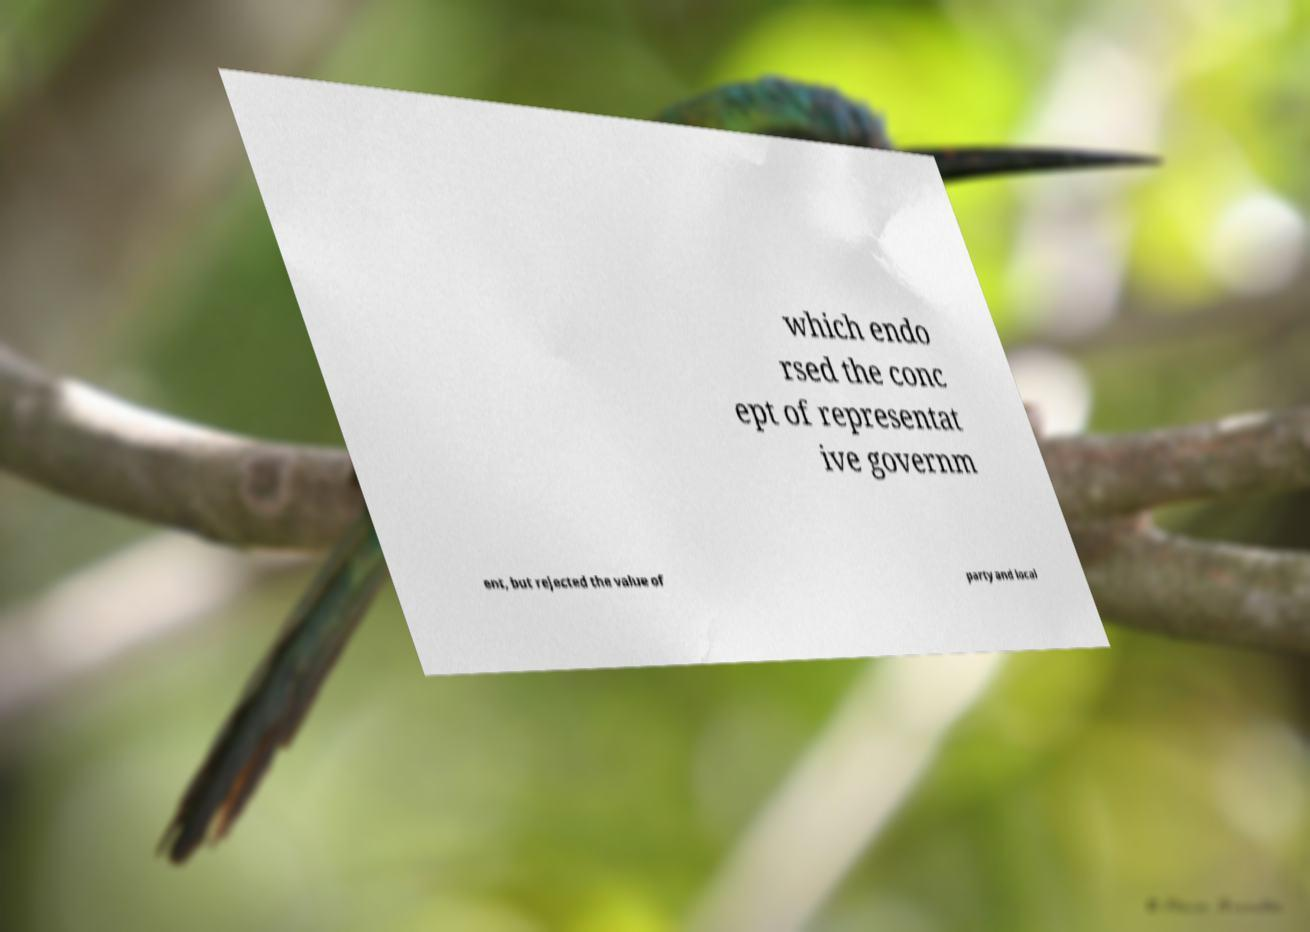I need the written content from this picture converted into text. Can you do that? which endo rsed the conc ept of representat ive governm ent, but rejected the value of party and local 